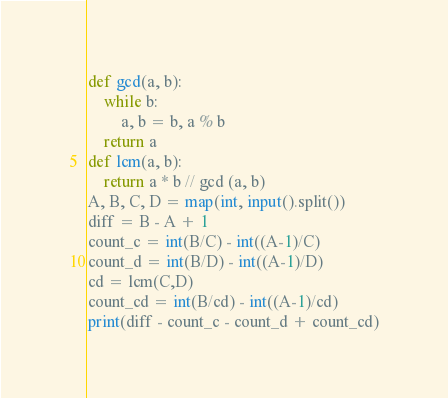Convert code to text. <code><loc_0><loc_0><loc_500><loc_500><_Python_>def gcd(a, b):
	while b:
		a, b = b, a % b
	return a
def lcm(a, b):
	return a * b // gcd (a, b)
A, B, C, D = map(int, input().split())
diff = B - A + 1
count_c = int(B/C) - int((A-1)/C)
count_d = int(B/D) - int((A-1)/D)
cd = lcm(C,D)
count_cd = int(B/cd) - int((A-1)/cd)
print(diff - count_c - count_d + count_cd)</code> 